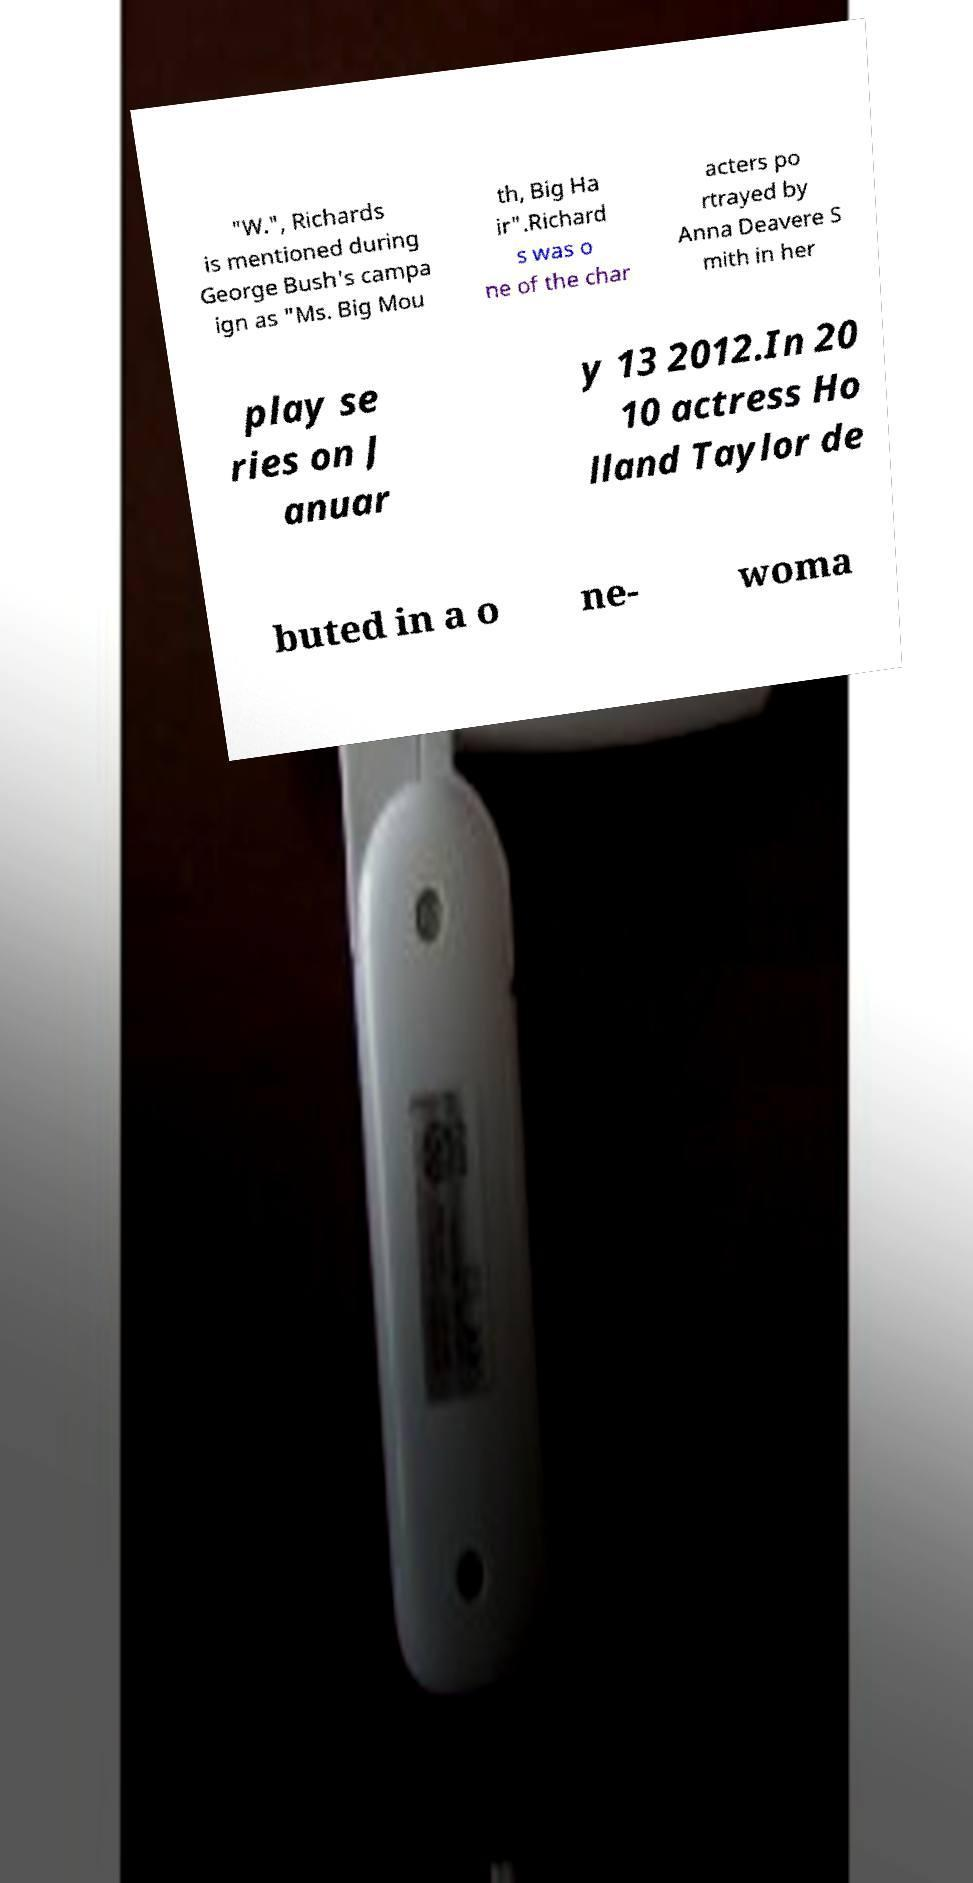There's text embedded in this image that I need extracted. Can you transcribe it verbatim? "W.", Richards is mentioned during George Bush's campa ign as "Ms. Big Mou th, Big Ha ir".Richard s was o ne of the char acters po rtrayed by Anna Deavere S mith in her play se ries on J anuar y 13 2012.In 20 10 actress Ho lland Taylor de buted in a o ne- woma 